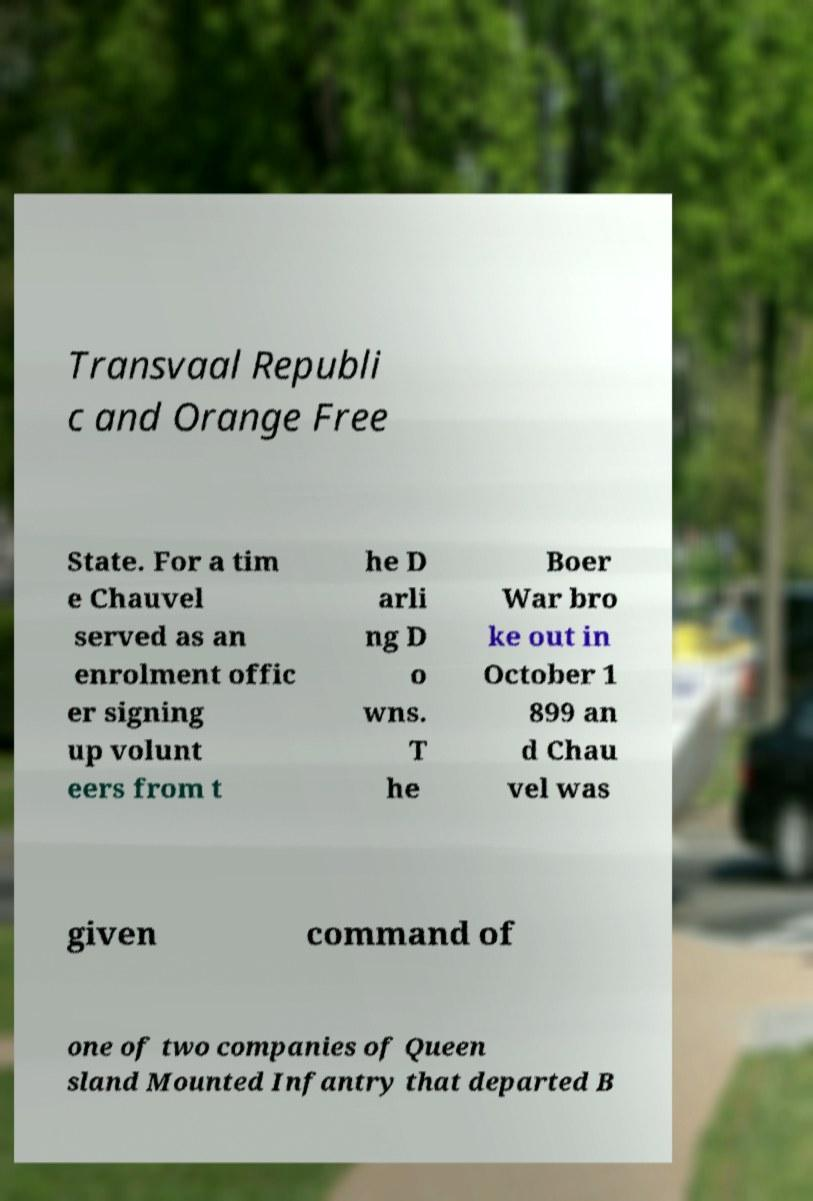I need the written content from this picture converted into text. Can you do that? Transvaal Republi c and Orange Free State. For a tim e Chauvel served as an enrolment offic er signing up volunt eers from t he D arli ng D o wns. T he Boer War bro ke out in October 1 899 an d Chau vel was given command of one of two companies of Queen sland Mounted Infantry that departed B 